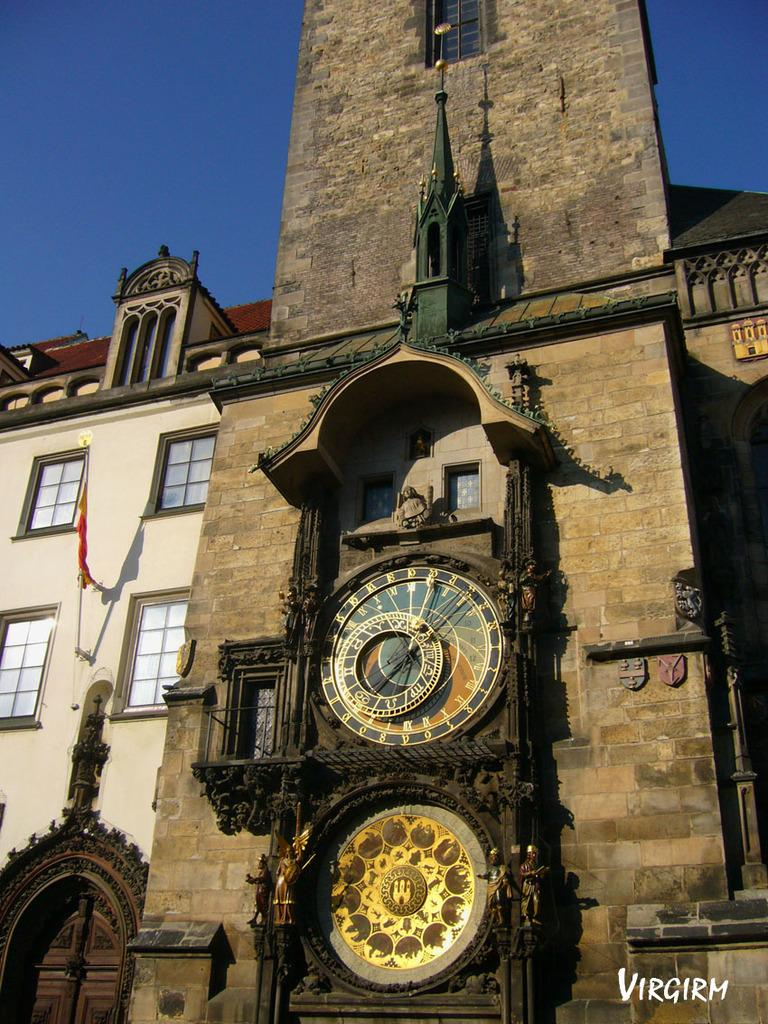What type of structure is present in the image? There is a building in the image. What feature can be observed on the building? The building has windows. What can be seen flying or hanging near the building? There is a red color flag in the image. What time-related object is visible in the image? There is a clock in the image. What part of the natural environment is visible in the image? The sky is visible in the image. Can you see any feathers falling from the sky in the image? There is no feather present in the image. What statement is being made by the building in the image? There is no statement being made by the building in the image; it is an inanimate object. 